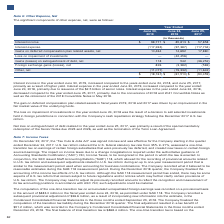According to Lam Research Corporation's financial document, What was the reason for the increase in interest income in 2019? According to the financial document, higher yield. The relevant text states: "2018, and June 25, 2017, primarily as a result of higher yield. Interest expense in the year ended June 30, 2019, increased compared to the year ended June 24, 20..." Also, What was the reason for the loss on impairment of investments in the year ended June 24, 2018? a decision to sell selected investments held in foreign jurisdictions in connection with the Company’s cash repatriation strategy following the December 2017 U.S. tax reform.. The document states: "in the year ended June 24, 2018 was the result of a decision to sell selected investments held in foreign jurisdictions in connection with the Company..." Also, What were the reasons for the net loss on extinguishment of debt realized in the year ended June 25, 2017? The document shows two values: the special mandatory redemption of the Senior Notes due 2023 and 2026 and the termination of the Term Loan Agreement. From the document: "of the Senior Notes due 2023 and 2026, as well as the termination of the Term Loan Agreement. ar ended June 25, 2017, was primarily a result of the sp..." Also, can you calculate: What is the percentage change in the interest income from 2018 to 2019? To answer this question, I need to perform calculations using the financial data. The calculation is: (98,771-85,813)/85,813, which equals 15.1 (percentage). This is based on the information: "Interest income $ 98,771 $ 85,813 $ 57,858 Interest income $ 98,771 $ 85,813 $ 57,858..." The key data points involved are: 85,813, 98,771. Also, can you calculate: What is the percentage change in the net gains on extinguishment of debt from 2018 to 2019? To answer this question, I need to perform calculations using the financial data. The calculation is: (118-542)/542, which equals -78.23 (percentage). This is based on the information: "Gains (losses) on extinguishment of debt, net 118 542 (36,252) Gains (losses) on extinguishment of debt, net 118 542 (36,252)..." The key data points involved are: 118, 542. Also, can you calculate: What is the percentage change in the foreign exchange losses from 2017 to 2018? To answer this question, I need to perform calculations using the financial data. The calculation is: (3,382-569)/569, which equals 494.38 (percentage). This is based on the information: "Foreign exchange gains (losses), net 826 (3,382) (569) Foreign exchange gains (losses), net 826 (3,382) (569)..." The key data points involved are: 3,382, 569. 